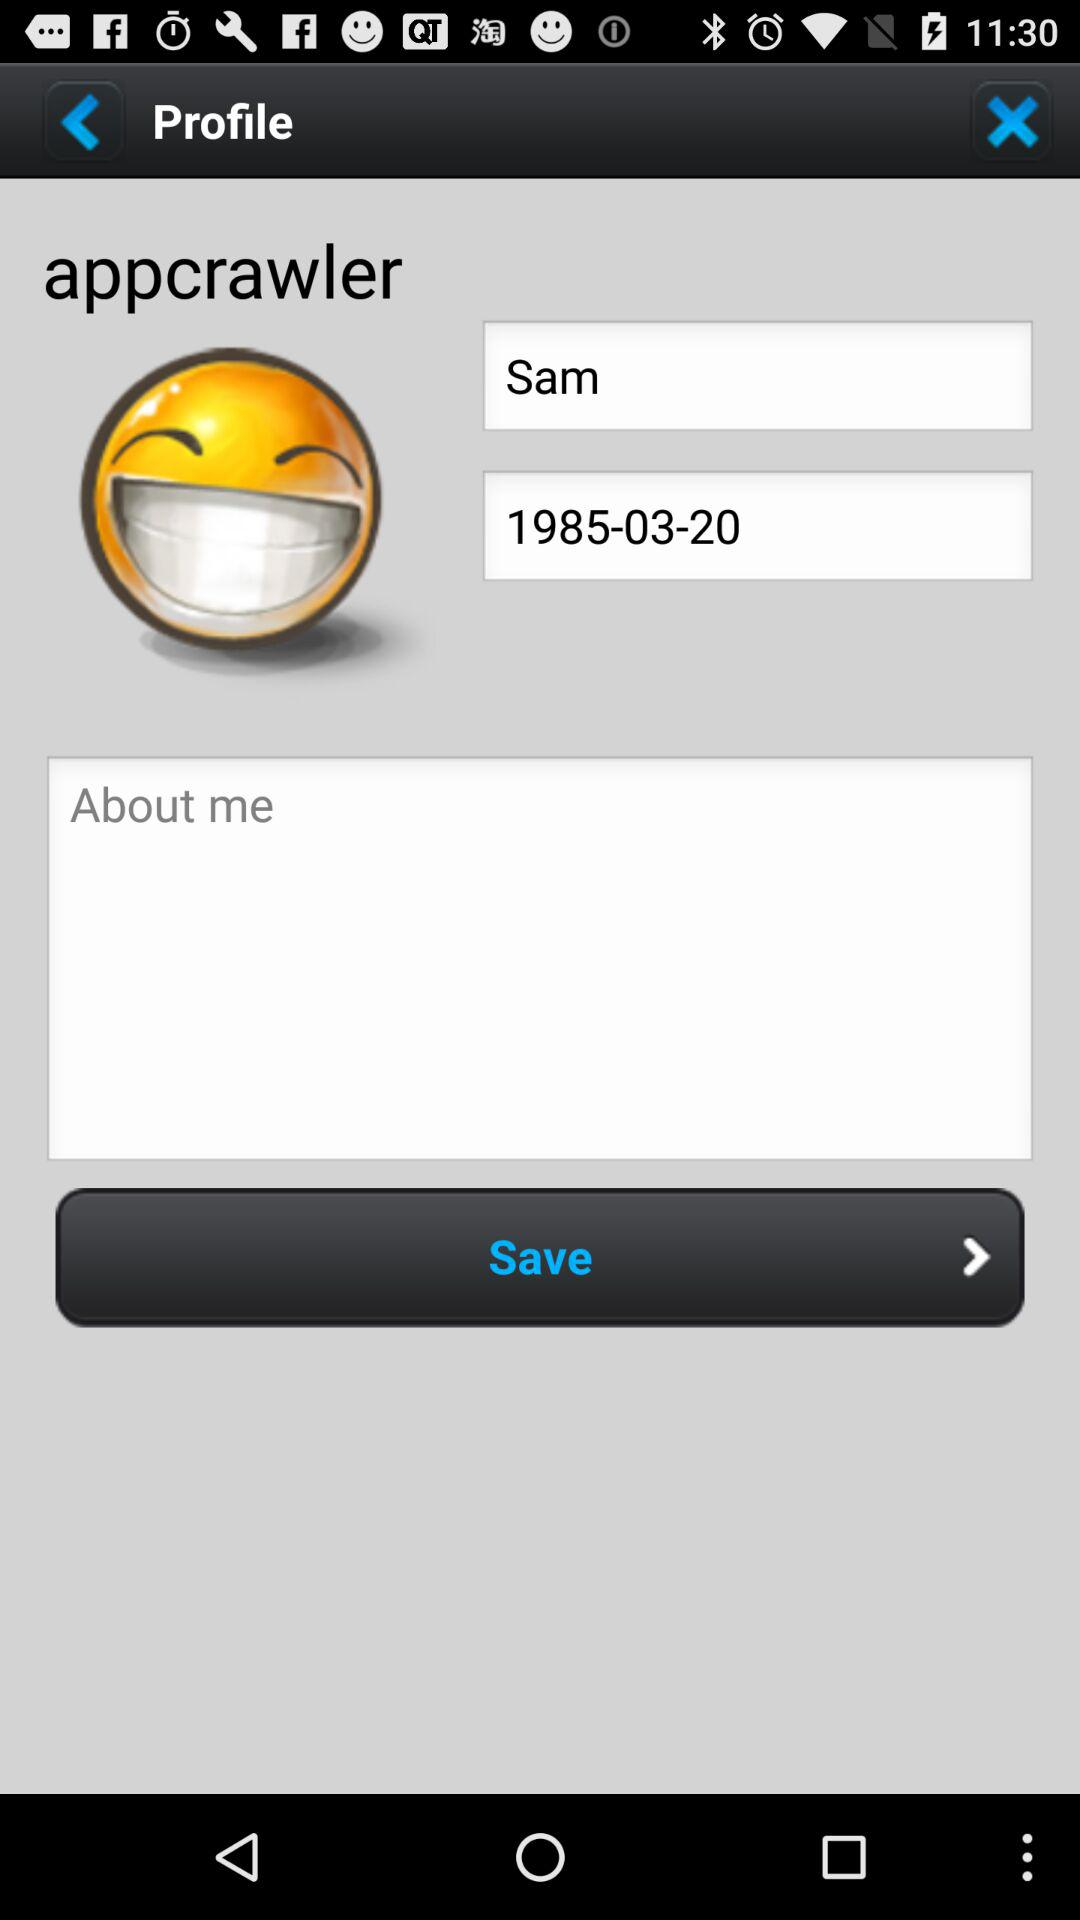What is the user name? The user name is Sam. 